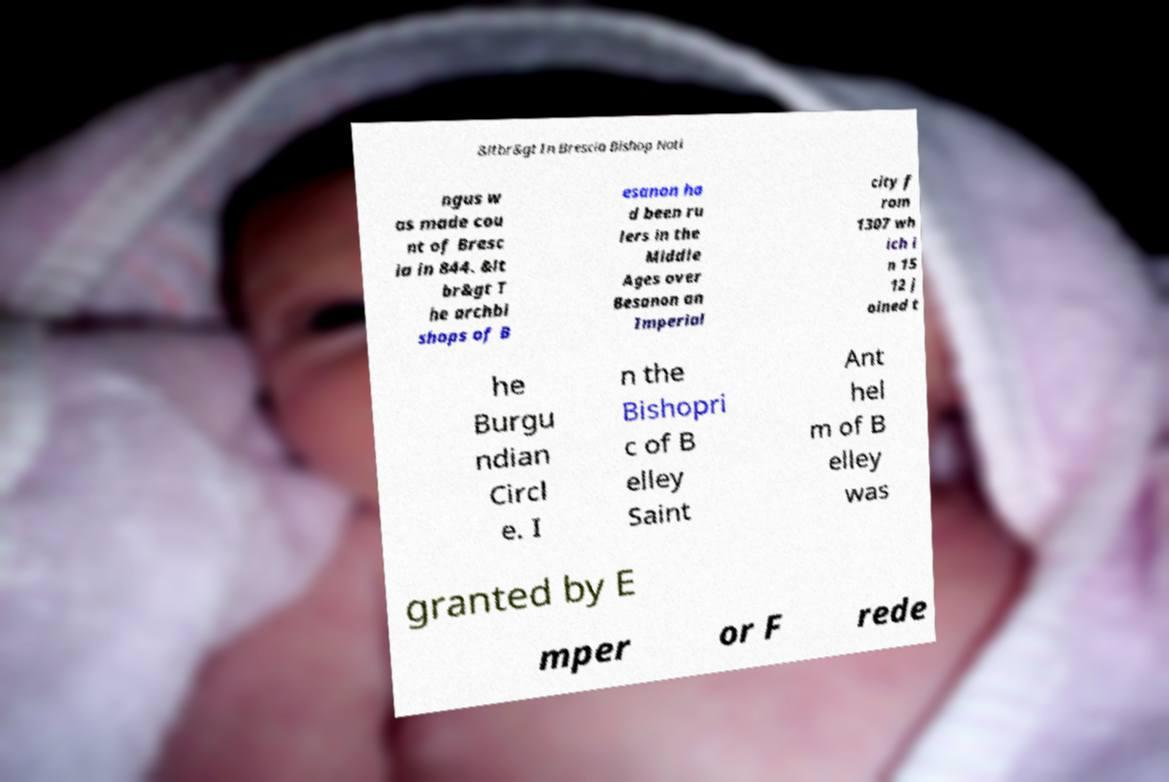There's text embedded in this image that I need extracted. Can you transcribe it verbatim? &ltbr&gt In Brescia Bishop Noti ngus w as made cou nt of Bresc ia in 844. &lt br&gt T he archbi shops of B esanon ha d been ru lers in the Middle Ages over Besanon an Imperial city f rom 1307 wh ich i n 15 12 j oined t he Burgu ndian Circl e. I n the Bishopri c of B elley Saint Ant hel m of B elley was granted by E mper or F rede 